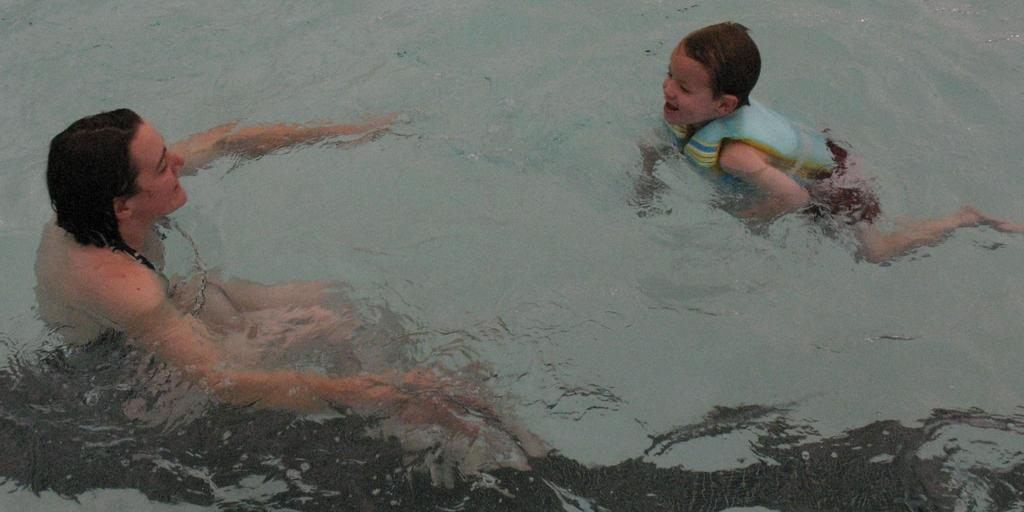Who is present in the image? There is a woman and a kid in the image. What are the woman and the kid doing in the image? Both the woman and the kid are swimming in the image. What is the primary element visible in the image? There is water visible in the image. What type of pollution can be seen in the image? There is no pollution visible in the image; it features a woman and a kid swimming in water. How many geese are present in the image? There are no geese present in the image. 